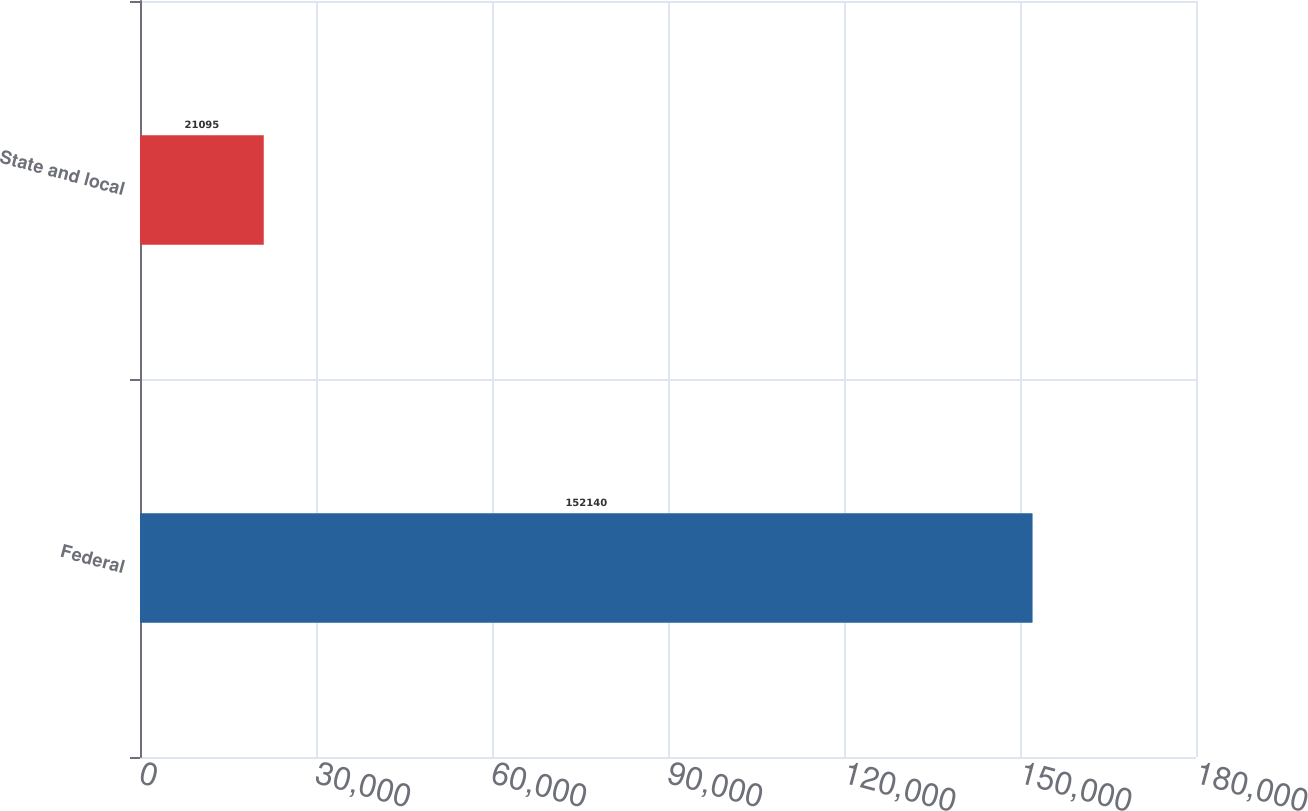Convert chart. <chart><loc_0><loc_0><loc_500><loc_500><bar_chart><fcel>Federal<fcel>State and local<nl><fcel>152140<fcel>21095<nl></chart> 